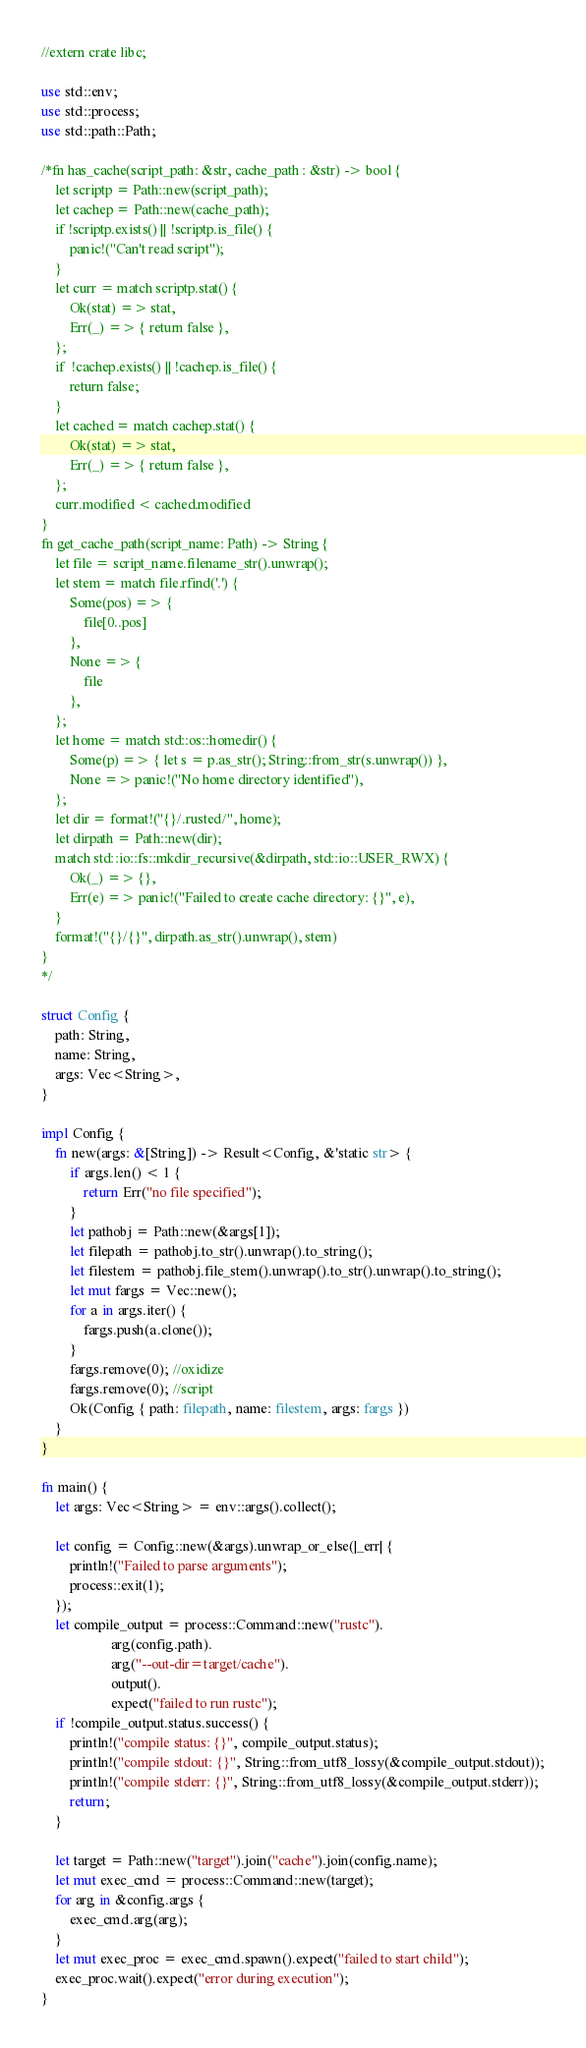Convert code to text. <code><loc_0><loc_0><loc_500><loc_500><_Rust_>//extern crate libc;

use std::env;
use std::process;
use std::path::Path;

/*fn has_cache(script_path: &str, cache_path : &str) -> bool {
    let scriptp = Path::new(script_path);
    let cachep = Path::new(cache_path);  
    if !scriptp.exists() || !scriptp.is_file() {
        panic!("Can't read script");
    }
    let curr = match scriptp.stat() {
        Ok(stat) => stat,
        Err(_) => { return false },
    };
    if  !cachep.exists() || !cachep.is_file() {
        return false;
    }
    let cached = match cachep.stat() {
        Ok(stat) => stat,
        Err(_) => { return false },
    };
    curr.modified < cached.modified
}
fn get_cache_path(script_name: Path) -> String {
    let file = script_name.filename_str().unwrap();
    let stem = match file.rfind('.') {
        Some(pos) => {
            file[0..pos]
        },
        None => {
            file
        },
    };
    let home = match std::os::homedir() {
        Some(p) => { let s = p.as_str(); String::from_str(s.unwrap()) },
        None => panic!("No home directory identified"),
    };
    let dir = format!("{}/.rusted/", home);
    let dirpath = Path::new(dir);
    match std::io::fs::mkdir_recursive(&dirpath, std::io::USER_RWX) {
        Ok(_) => {},
        Err(e) => panic!("Failed to create cache directory: {}", e),
    }
    format!("{}/{}", dirpath.as_str().unwrap(), stem)
}
*/

struct Config {
    path: String,
    name: String,
    args: Vec<String>, 
}

impl Config {
    fn new(args: &[String]) -> Result<Config, &'static str> {
        if args.len() < 1 {
            return Err("no file specified");
        }
        let pathobj = Path::new(&args[1]);
        let filepath = pathobj.to_str().unwrap().to_string();
        let filestem = pathobj.file_stem().unwrap().to_str().unwrap().to_string();
        let mut fargs = Vec::new();
        for a in args.iter() {
            fargs.push(a.clone());
        }
        fargs.remove(0); //oxidize
        fargs.remove(0); //script
        Ok(Config { path: filepath, name: filestem, args: fargs })
    }
}

fn main() {
    let args: Vec<String> = env::args().collect();

    let config = Config::new(&args).unwrap_or_else(|_err| {
        println!("Failed to parse arguments");
        process::exit(1);
    });
    let compile_output = process::Command::new("rustc").
                    arg(config.path).
                    arg("--out-dir=target/cache").
                    output().
                    expect("failed to run rustc");
    if !compile_output.status.success() {
        println!("compile status: {}", compile_output.status);
        println!("compile stdout: {}", String::from_utf8_lossy(&compile_output.stdout));
        println!("compile stderr: {}", String::from_utf8_lossy(&compile_output.stderr));
        return;
    }

    let target = Path::new("target").join("cache").join(config.name);
    let mut exec_cmd = process::Command::new(target);
    for arg in &config.args {
        exec_cmd.arg(arg);
    }
    let mut exec_proc = exec_cmd.spawn().expect("failed to start child");
    exec_proc.wait().expect("error during execution");
}
</code> 